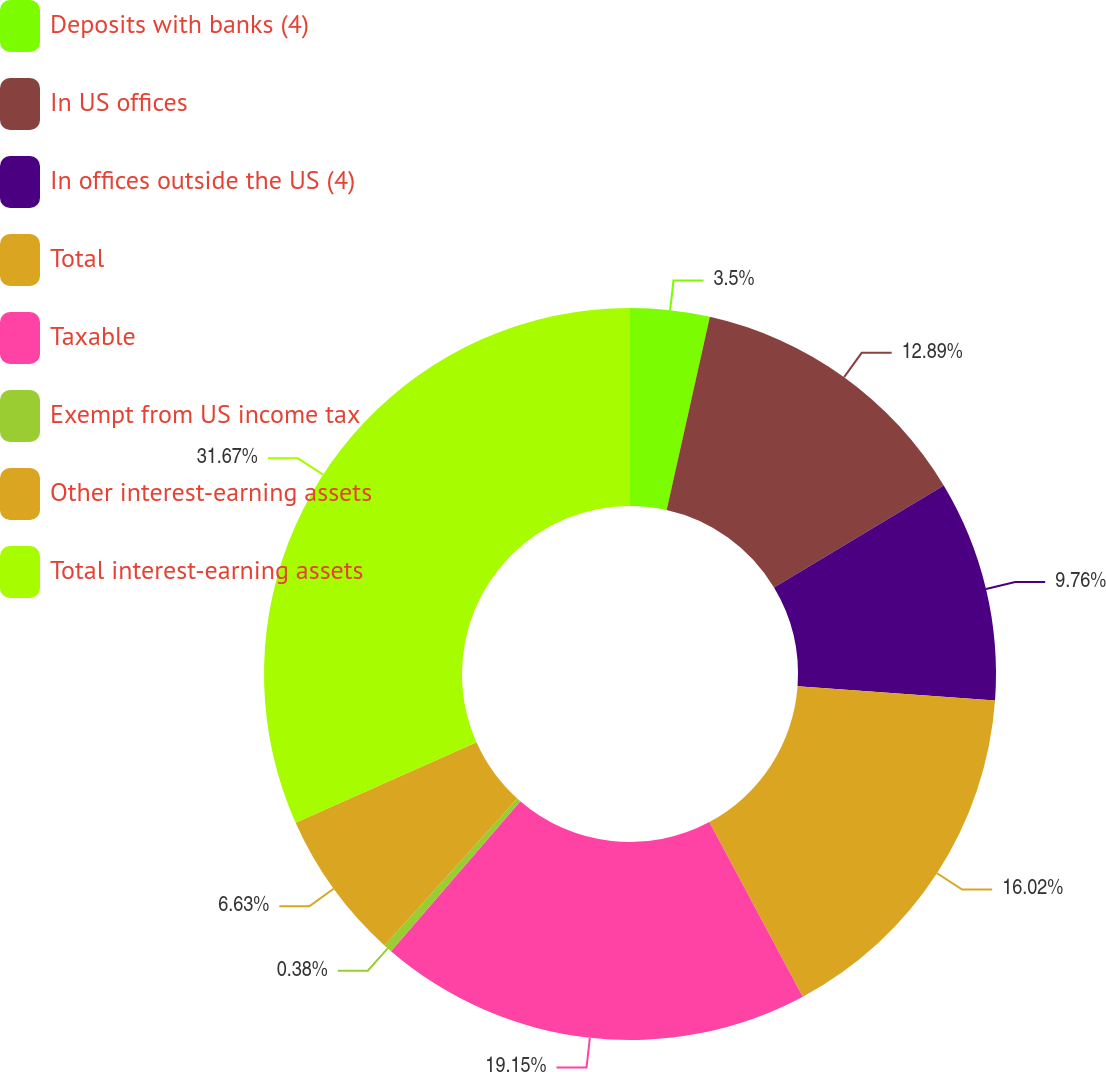Convert chart. <chart><loc_0><loc_0><loc_500><loc_500><pie_chart><fcel>Deposits with banks (4)<fcel>In US offices<fcel>In offices outside the US (4)<fcel>Total<fcel>Taxable<fcel>Exempt from US income tax<fcel>Other interest-earning assets<fcel>Total interest-earning assets<nl><fcel>3.5%<fcel>12.89%<fcel>9.76%<fcel>16.02%<fcel>19.15%<fcel>0.38%<fcel>6.63%<fcel>31.66%<nl></chart> 